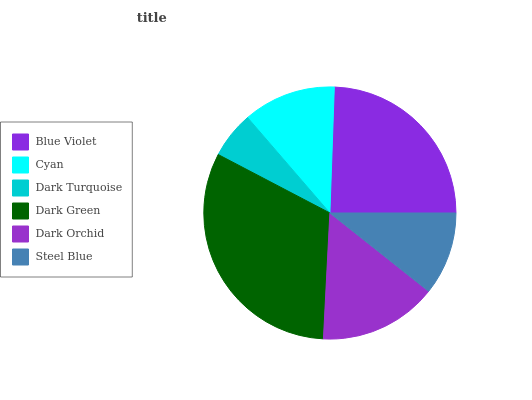Is Dark Turquoise the minimum?
Answer yes or no. Yes. Is Dark Green the maximum?
Answer yes or no. Yes. Is Cyan the minimum?
Answer yes or no. No. Is Cyan the maximum?
Answer yes or no. No. Is Blue Violet greater than Cyan?
Answer yes or no. Yes. Is Cyan less than Blue Violet?
Answer yes or no. Yes. Is Cyan greater than Blue Violet?
Answer yes or no. No. Is Blue Violet less than Cyan?
Answer yes or no. No. Is Dark Orchid the high median?
Answer yes or no. Yes. Is Cyan the low median?
Answer yes or no. Yes. Is Dark Green the high median?
Answer yes or no. No. Is Dark Green the low median?
Answer yes or no. No. 